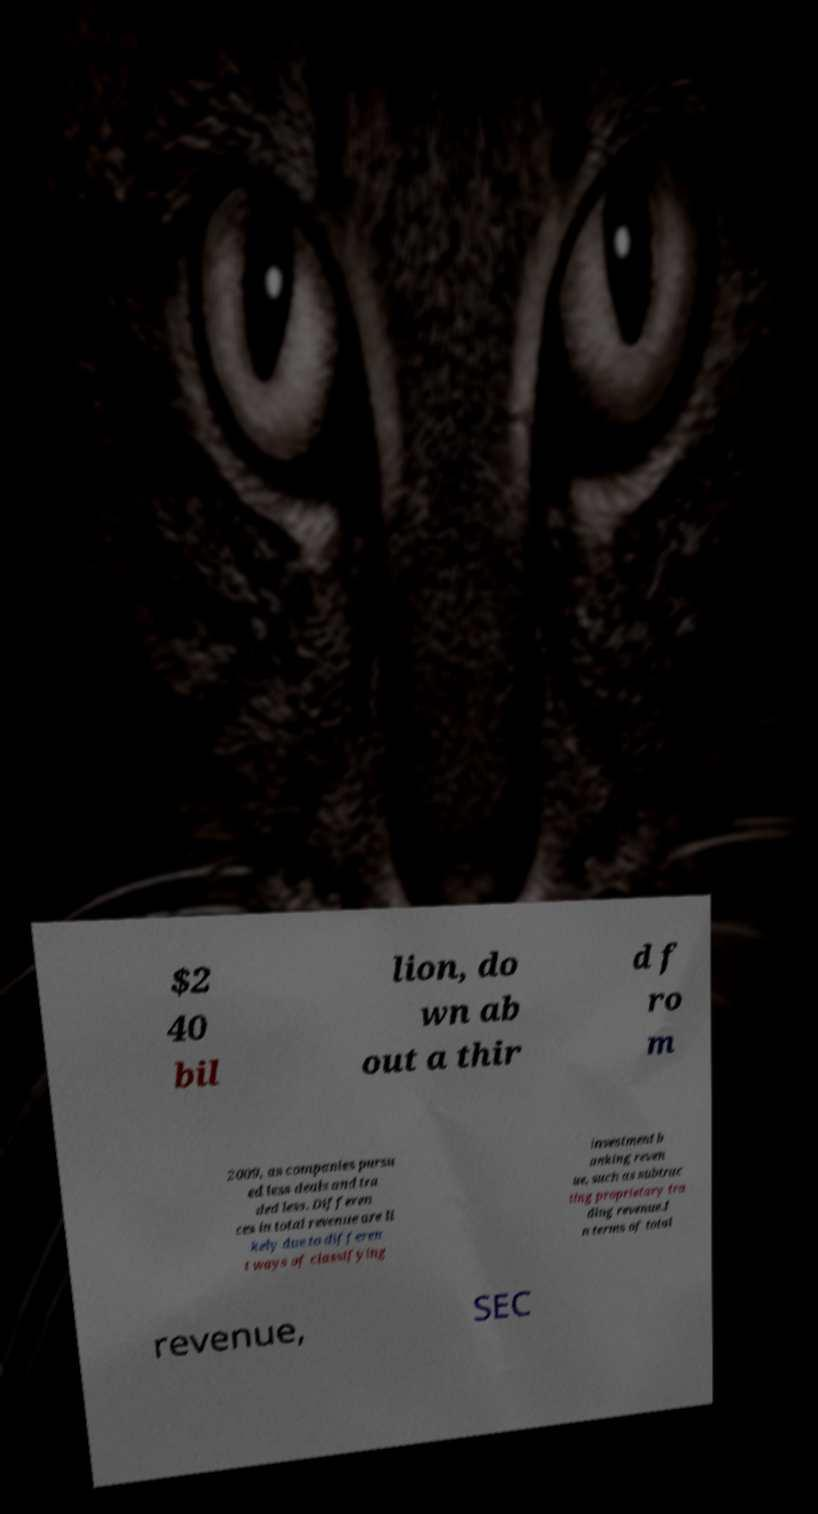There's text embedded in this image that I need extracted. Can you transcribe it verbatim? $2 40 bil lion, do wn ab out a thir d f ro m 2009, as companies pursu ed less deals and tra ded less. Differen ces in total revenue are li kely due to differen t ways of classifying investment b anking reven ue, such as subtrac ting proprietary tra ding revenue.I n terms of total revenue, SEC 